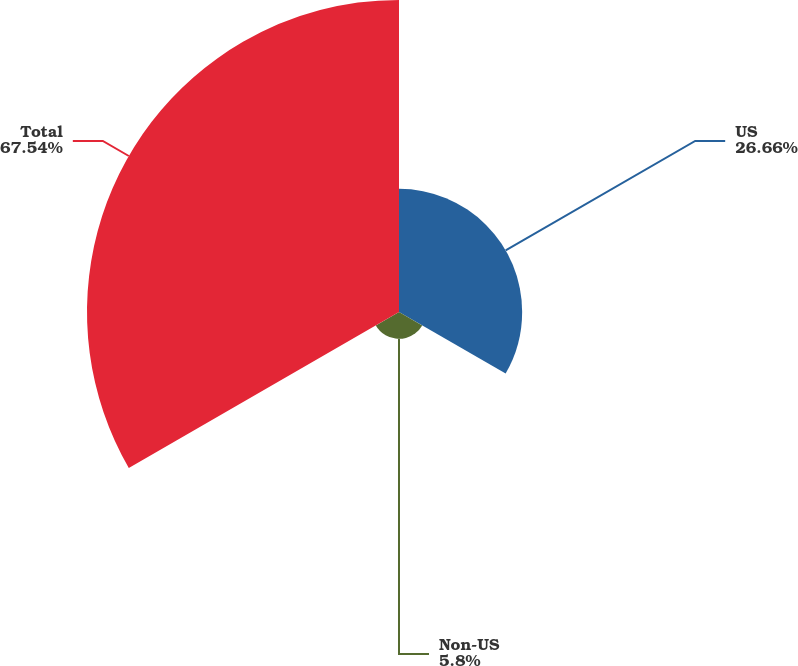Convert chart. <chart><loc_0><loc_0><loc_500><loc_500><pie_chart><fcel>US<fcel>Non-US<fcel>Total<nl><fcel>26.66%<fcel>5.8%<fcel>67.54%<nl></chart> 